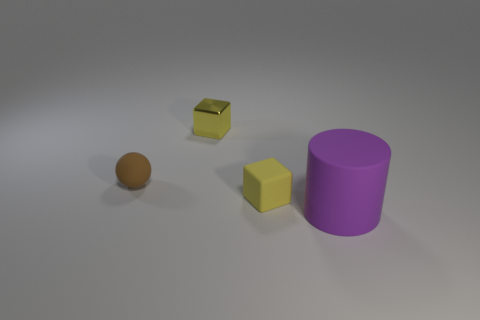How many yellow blocks must be subtracted to get 1 yellow blocks? 1 Add 4 large purple cylinders. How many objects exist? 8 Subtract all cylinders. How many objects are left? 3 Subtract 1 blocks. How many blocks are left? 1 Subtract all blue cylinders. Subtract all purple spheres. How many cylinders are left? 1 Subtract all cyan cylinders. How many red cubes are left? 0 Subtract all tiny spheres. Subtract all big purple balls. How many objects are left? 3 Add 4 tiny brown rubber balls. How many tiny brown rubber balls are left? 5 Add 3 tiny yellow shiny things. How many tiny yellow shiny things exist? 4 Subtract 0 red cylinders. How many objects are left? 4 